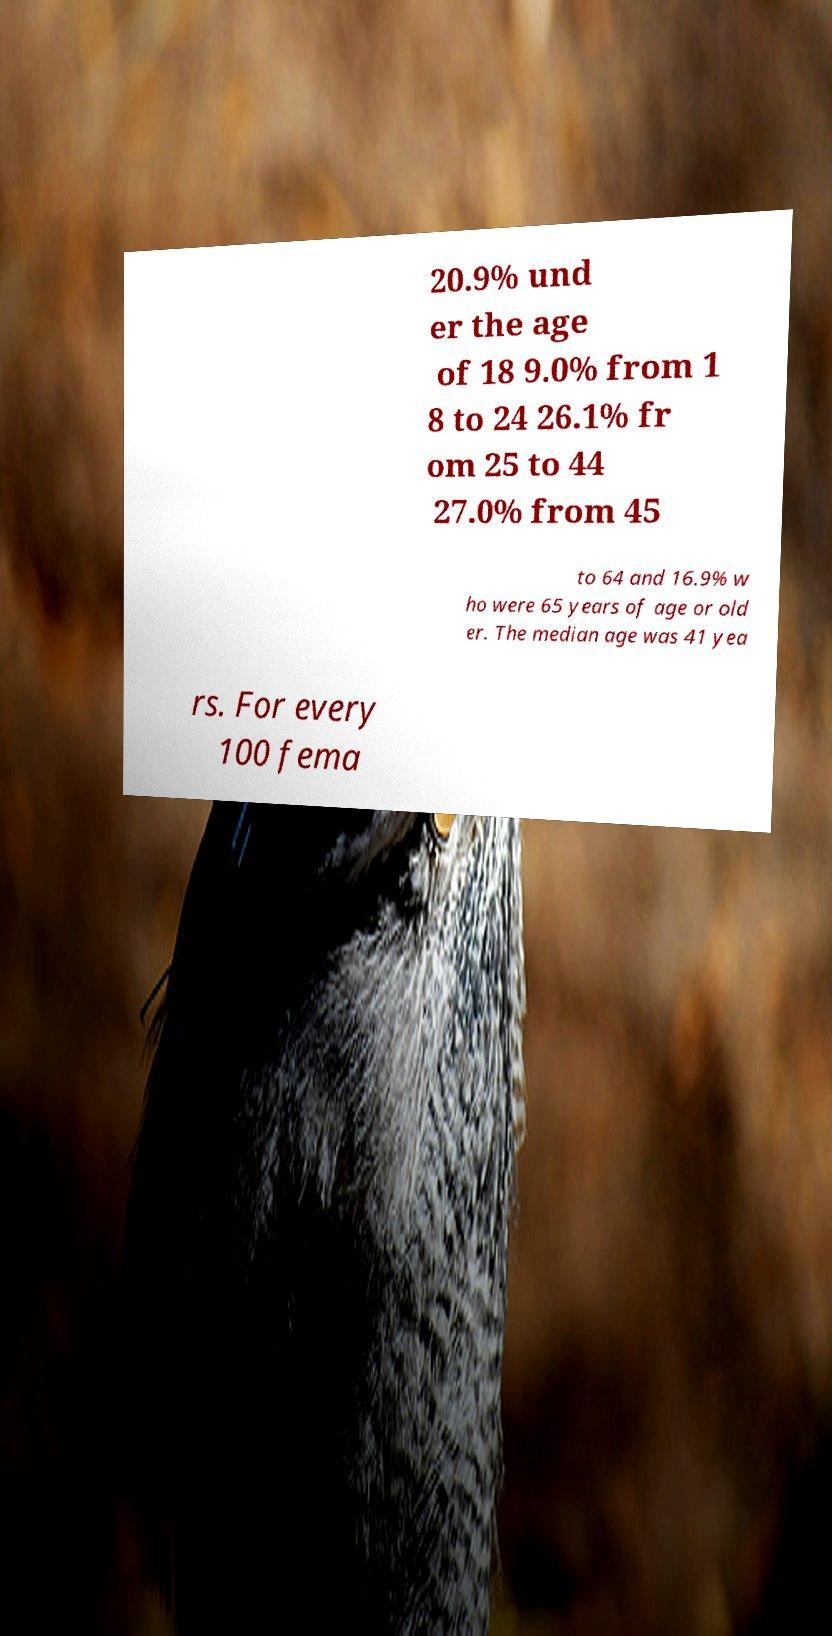Could you extract and type out the text from this image? 20.9% und er the age of 18 9.0% from 1 8 to 24 26.1% fr om 25 to 44 27.0% from 45 to 64 and 16.9% w ho were 65 years of age or old er. The median age was 41 yea rs. For every 100 fema 